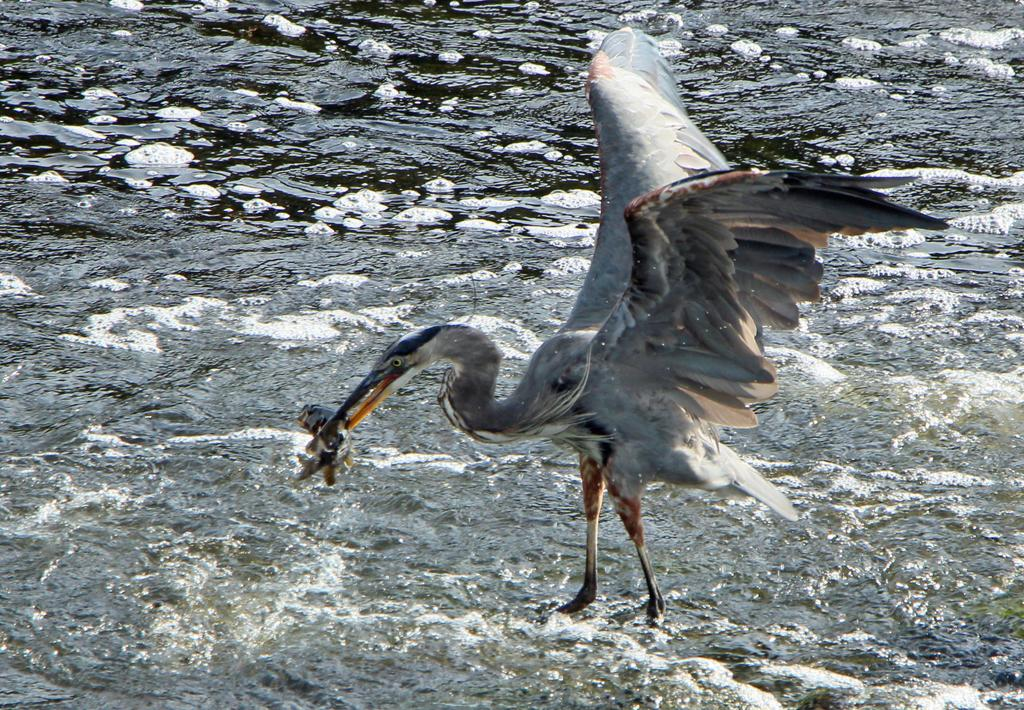What animal is the main subject of the image? There is a swan in the image. What is the swan doing in the image? The swan is holding a fish in its mouth. What body of water is visible in the image? There is a river at the bottom of the image. How many stitches are required to mend the swan's wing in the image? There is no indication in the image that the swan's wing is damaged or requires mending. 